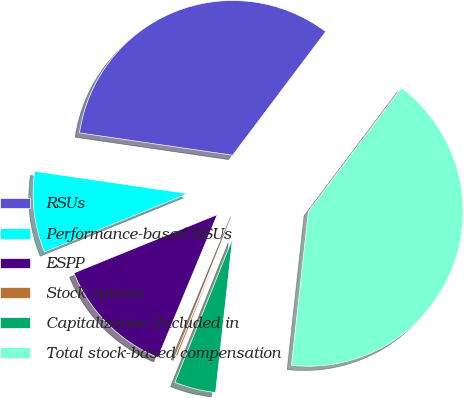Convert chart. <chart><loc_0><loc_0><loc_500><loc_500><pie_chart><fcel>RSUs<fcel>Performance-based RSUs<fcel>ESPP<fcel>Stock options<fcel>Capitalization (Included in<fcel>Total stock-based compensation<nl><fcel>32.96%<fcel>8.46%<fcel>12.58%<fcel>0.2%<fcel>4.33%<fcel>41.47%<nl></chart> 